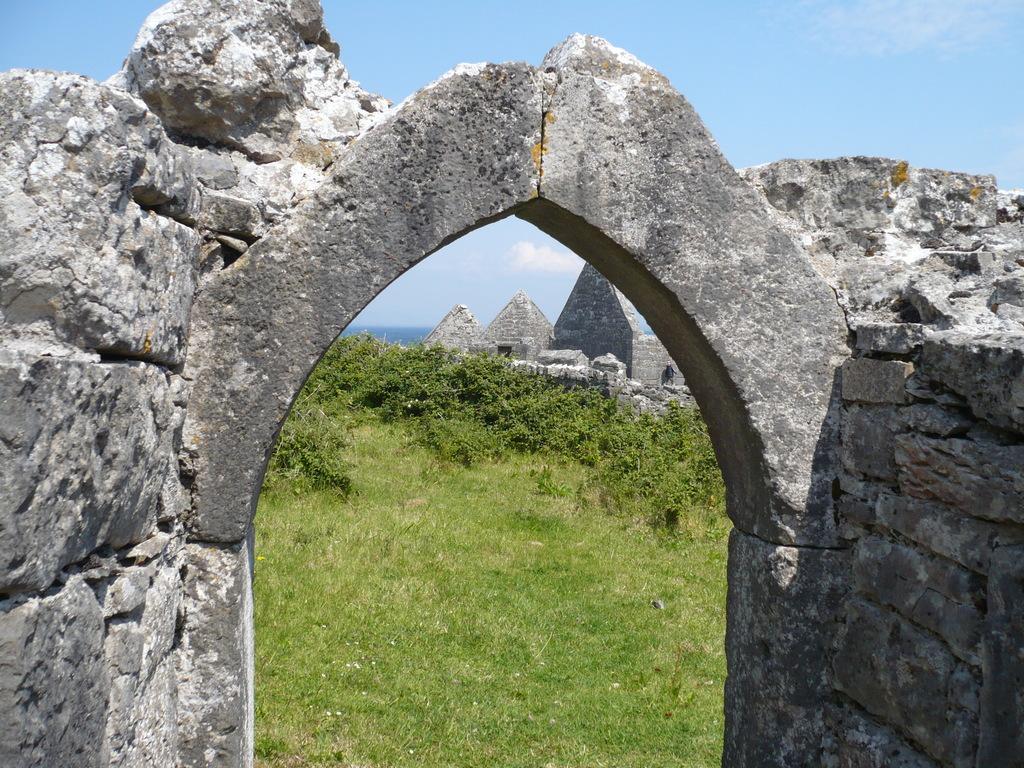Can you describe this image briefly? In this picture we can see an arch, grass, trees, walls, stones and in the background we can see the sky. 